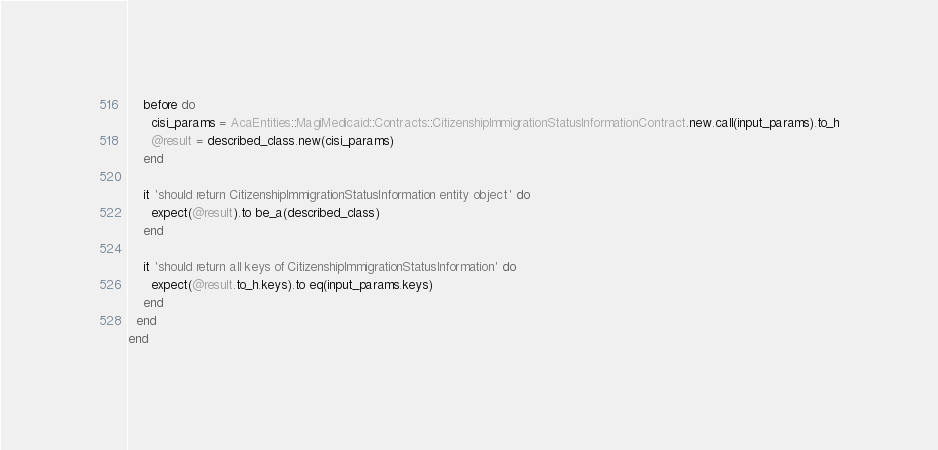<code> <loc_0><loc_0><loc_500><loc_500><_Ruby_>
    before do
      cisi_params = AcaEntities::MagiMedicaid::Contracts::CitizenshipImmigrationStatusInformationContract.new.call(input_params).to_h
      @result = described_class.new(cisi_params)
    end

    it 'should return CitizenshipImmigrationStatusInformation entity object' do
      expect(@result).to be_a(described_class)
    end

    it 'should return all keys of CitizenshipImmigrationStatusInformation' do
      expect(@result.to_h.keys).to eq(input_params.keys)
    end
  end
end
</code> 